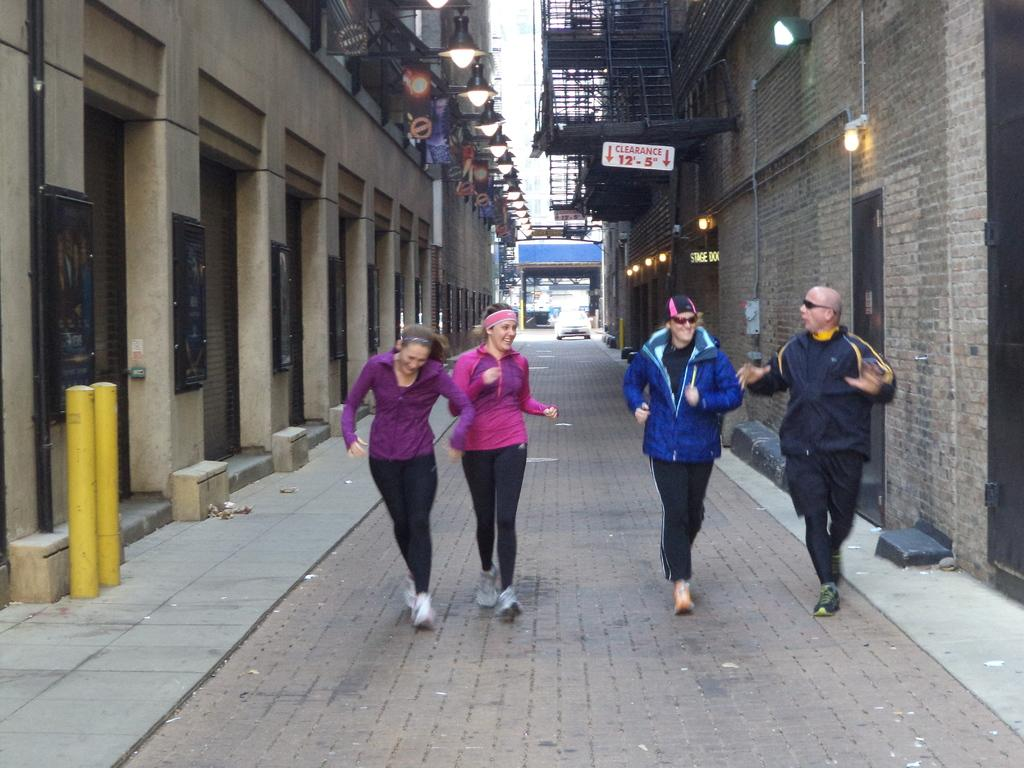What are the people in the image doing? The people in the image are running on the walkway. What can be seen on the left side of the image? There are buildings on the left side of the image. What can be seen on the right side of the image? There are buildings on the right side of the image. What is providing illumination in the image? There are lights visible in the image. What is located in the background of the image? There is a vehicle in the background of the image. What is the tendency of the airport in the image? There is no airport present in the image. Is there a meeting taking place in the image? There is no indication of a meeting in the image. 